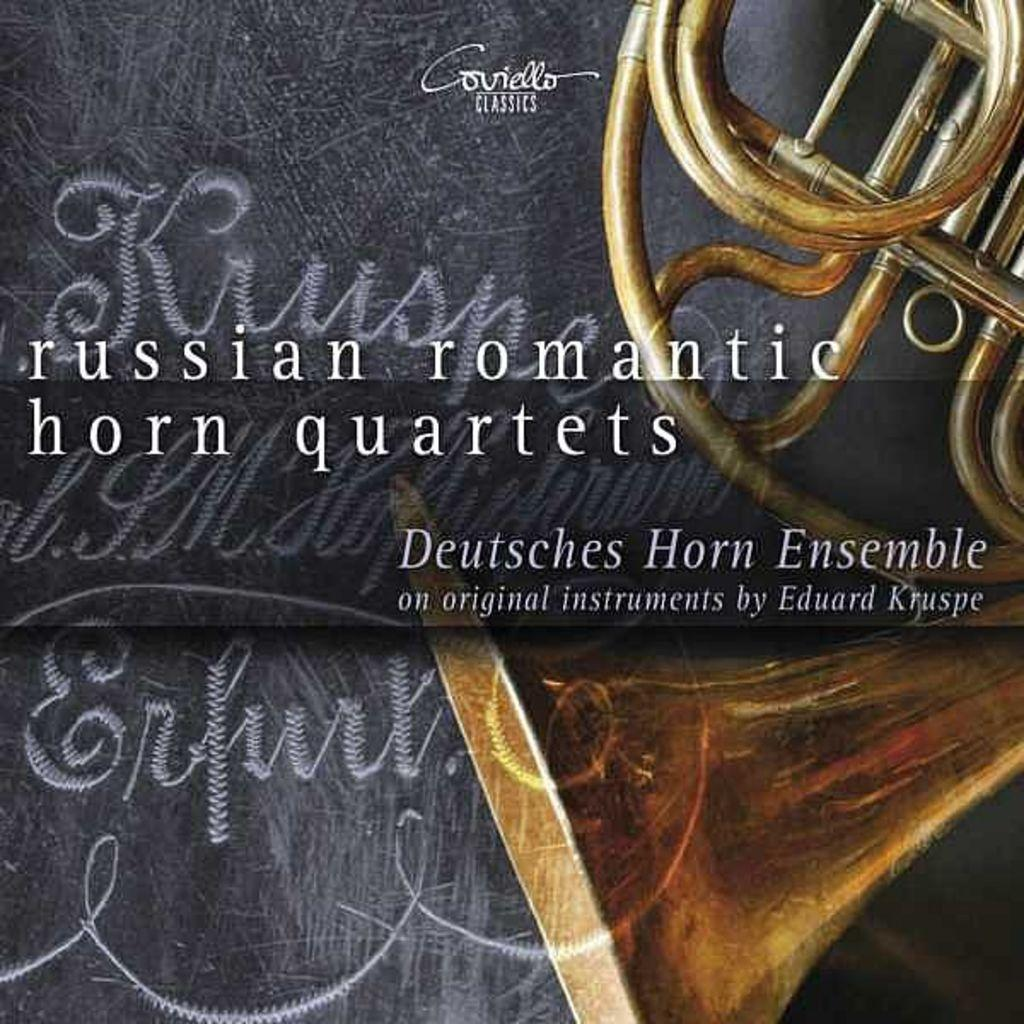What is featured in the image? There is a poster in the image. What can be found on the poster? There is text on the poster. Where are the pipes located in the image? The pipes are in the top right corner of the image. Can you see the friend holding a pail in the image? There is no friend or pail present in the image. 